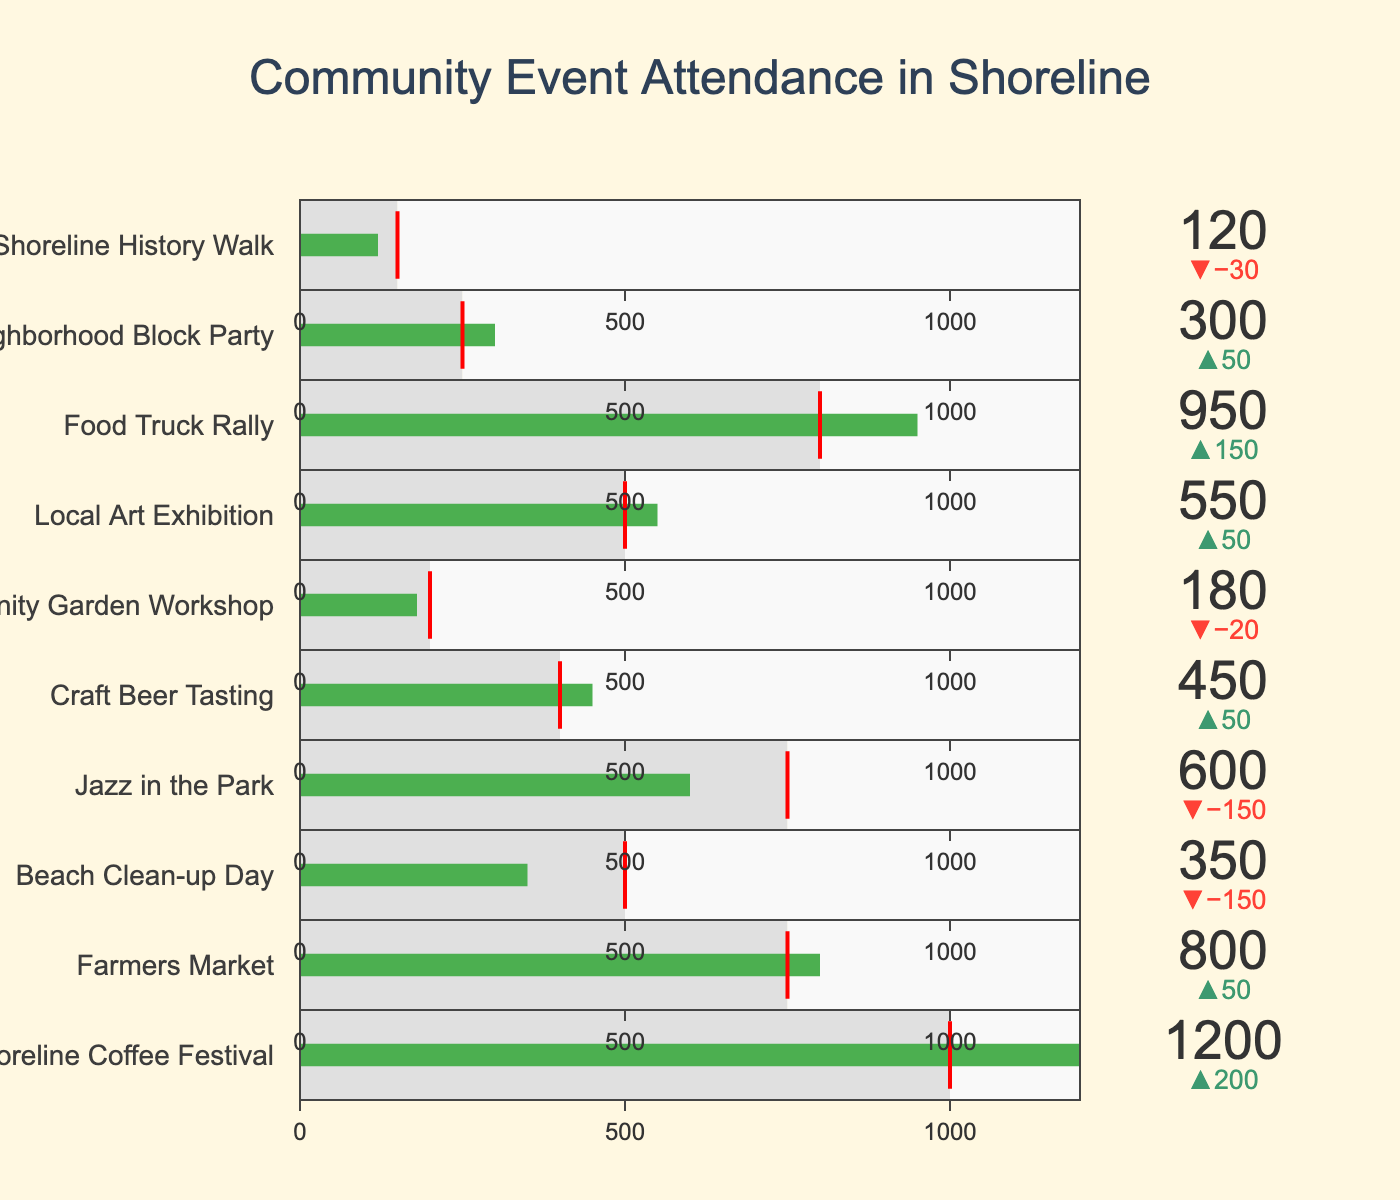What's the title of the figure? Look at the top of the figure, the title is prominently displayed.
Answer: Community Event Attendance in Shoreline What is the goal attendance for Jazz in the Park? Locate the Jazz in the Park plot. The goal attendance is indicated by the red threshold line.
Answer: 750 Which event had the highest actual attendance? Observe the value displayed on each indicator. The event with the highest number is the Shoreline Coffee Festival.
Answer: Shoreline Coffee Festival Did the Beach Clean-up Day event meet its goal attendance? Compare the actual attendance bar with the red threshold line for Beach Clean-up Day. The actual attendance is below the threshold.
Answer: No By how much did the Craft Beer Tasting exceed its goal? Look at the delta value for Craft Beer Tasting, which shows the difference between actual attendance and goal attendance.
Answer: 50 Which events had lower actual attendance than their goals? Identify the events where the actual attendance bars are shorter than the red threshold lines: Beach Clean-up Day, Jazz in the Park, Community Garden Workshop, Shoreline History Walk.
Answer: Beach Clean-up Day, Jazz in the Park, Community Garden Workshop, Shoreline History Walk What is the sum of the actual attendances for Shoreline Coffee Festival, Farmers Market, and Beach Clean-up Day? Add the actual attendance values for these three events: 1200 (Shoreline Coffee Festival) + 800 (Farmers Market) + 350 (Beach Clean-up Day).
Answer: 2350 On average, how much did all events exceed or fall short of their goals? Calculate the differences for each event, sum them up, and divide by the number of events: [(1200-1000) + (800-750) + (350-500) + (600-750) + (450-400) + (180-200) + (550-500) + (950-800) + (300-250) + (120-150)] / 10
Answer: 25 Which event had the smallest difference between actual and goal attendance? Compare the delta values for all events, the smallest difference in absolute value is for the Community Garden Workshop.
Answer: Community Garden Workshop How much more attended was the Food Truck Rally compared to the Neighborhood Block Party? Subtract the actual attendance of the Neighborhood Block Party from the Food Truck Rally: 950 (Food Truck Rally) - 300 (Neighborhood Block Party).
Answer: 650 